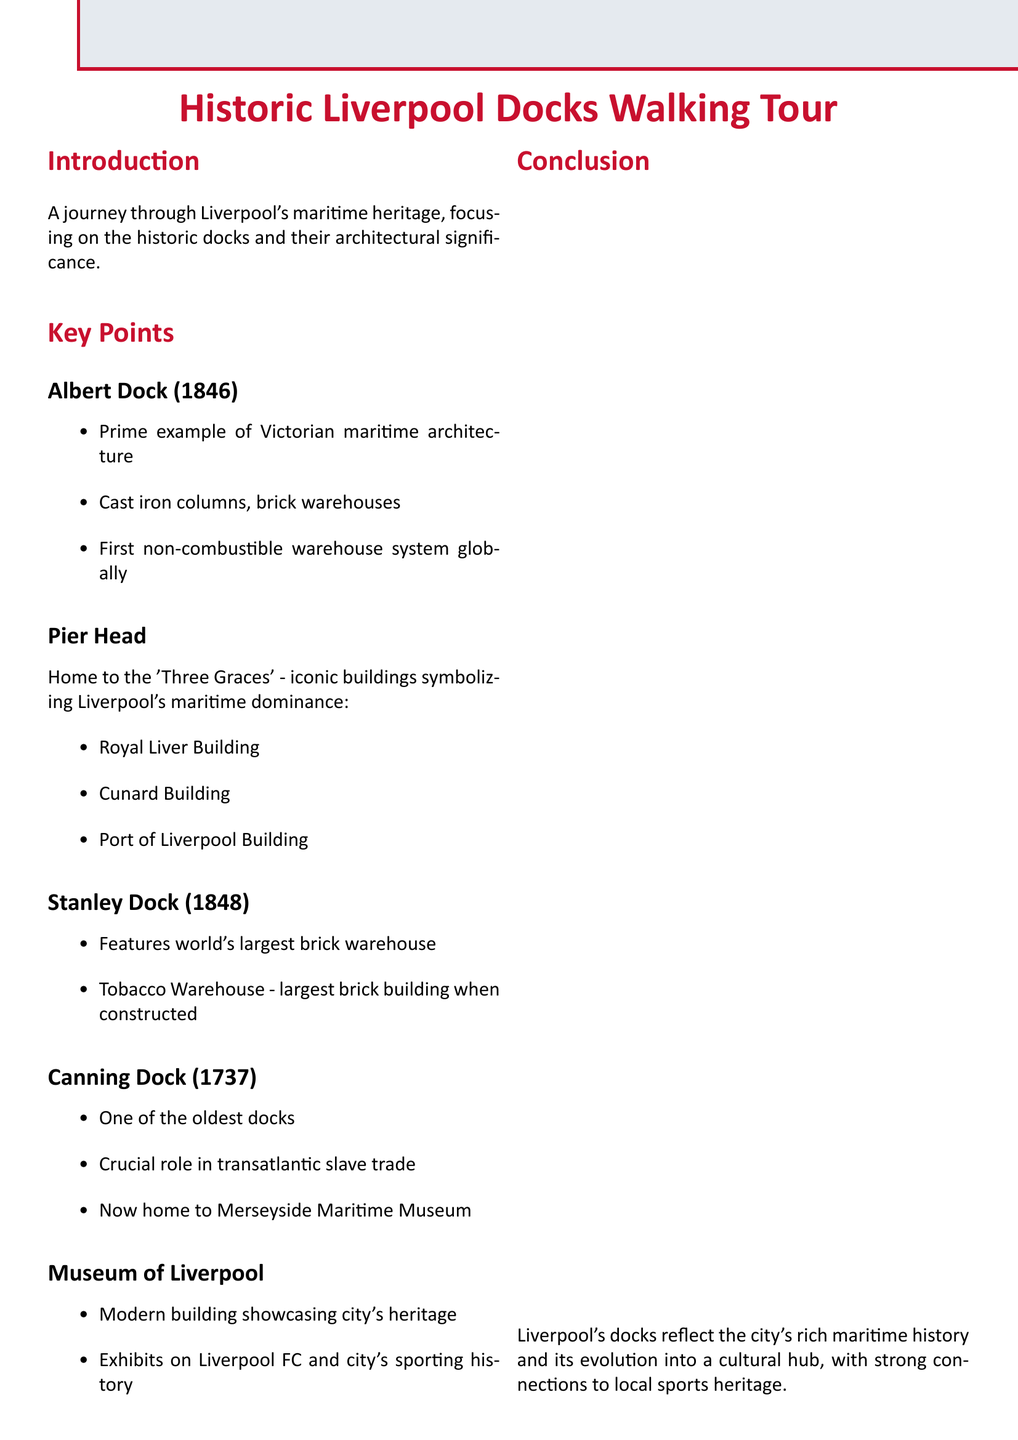What year was Albert Dock opened? The document states that Albert Dock was opened in 1846.
Answer: 1846 What is the significance of Canning Dock? Canning Dock is mentioned as one of the oldest docks, opened in 1737, and it played a crucial role in the transatlantic slave trade.
Answer: Crucial role in transatlantic slave trade Which buildings are referred to as the 'Three Graces'? The document names the Royal Liver Building, Cunard Building, and Port of Liverpool Building as the 'Three Graces'.
Answer: Royal Liver Building, Cunard Building, Port of Liverpool Building What modern feature is found at Canning Dock? It is noted that Canning Dock is now home to the Merseyside Maritime Museum.
Answer: Merseyside Maritime Museum What was the Tobacco Warehouse's significance? The Tobacco Warehouse is highlighted as the largest brick building in the world when it was constructed.
Answer: Largest brick building in the world What type of architecture does Albert Dock represent? The document describes Albert Dock as a prime example of Victorian maritime architecture.
Answer: Victorian maritime architecture What prominent sport-related exhibit does the Museum of Liverpool feature? The document mentions exhibits on Liverpool FC as part of the museum's showcases.
Answer: Exhibits on Liverpool FC What is the focus of the walking tour? The introduction states that the tour focuses on Liverpool's maritime heritage and historic docks.
Answer: Liverpool's maritime heritage and historic docks 